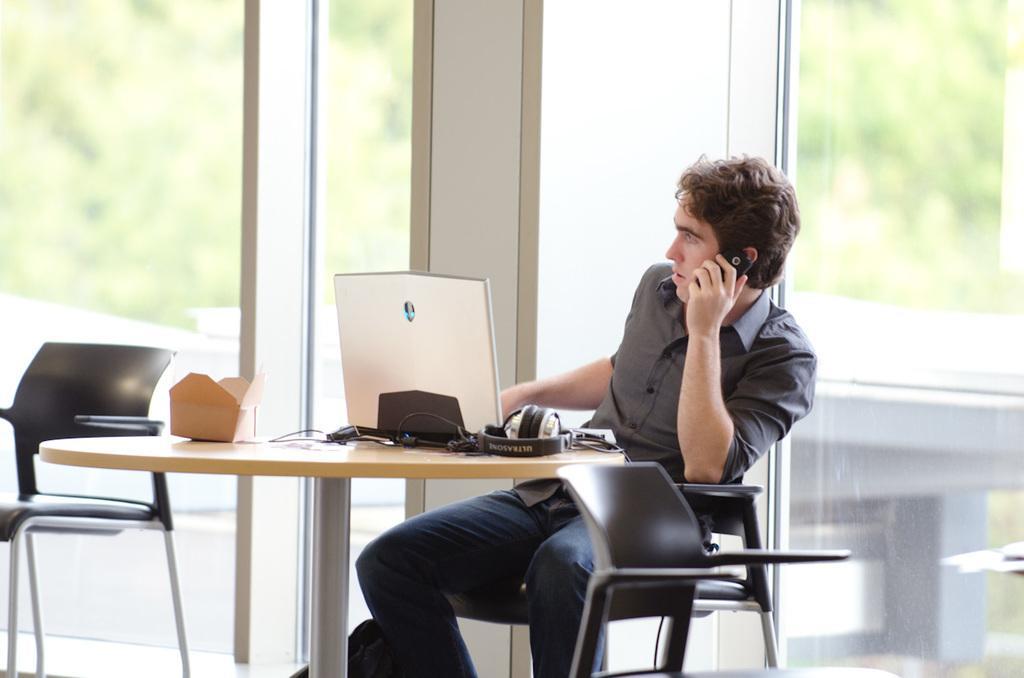Can you describe this image briefly? In this image we can see a person sitting on the chair near table is holding a mobile phone in his hands. There are headphones, laptop on the table. In the background we can see a glass window through which trees can be seen. 